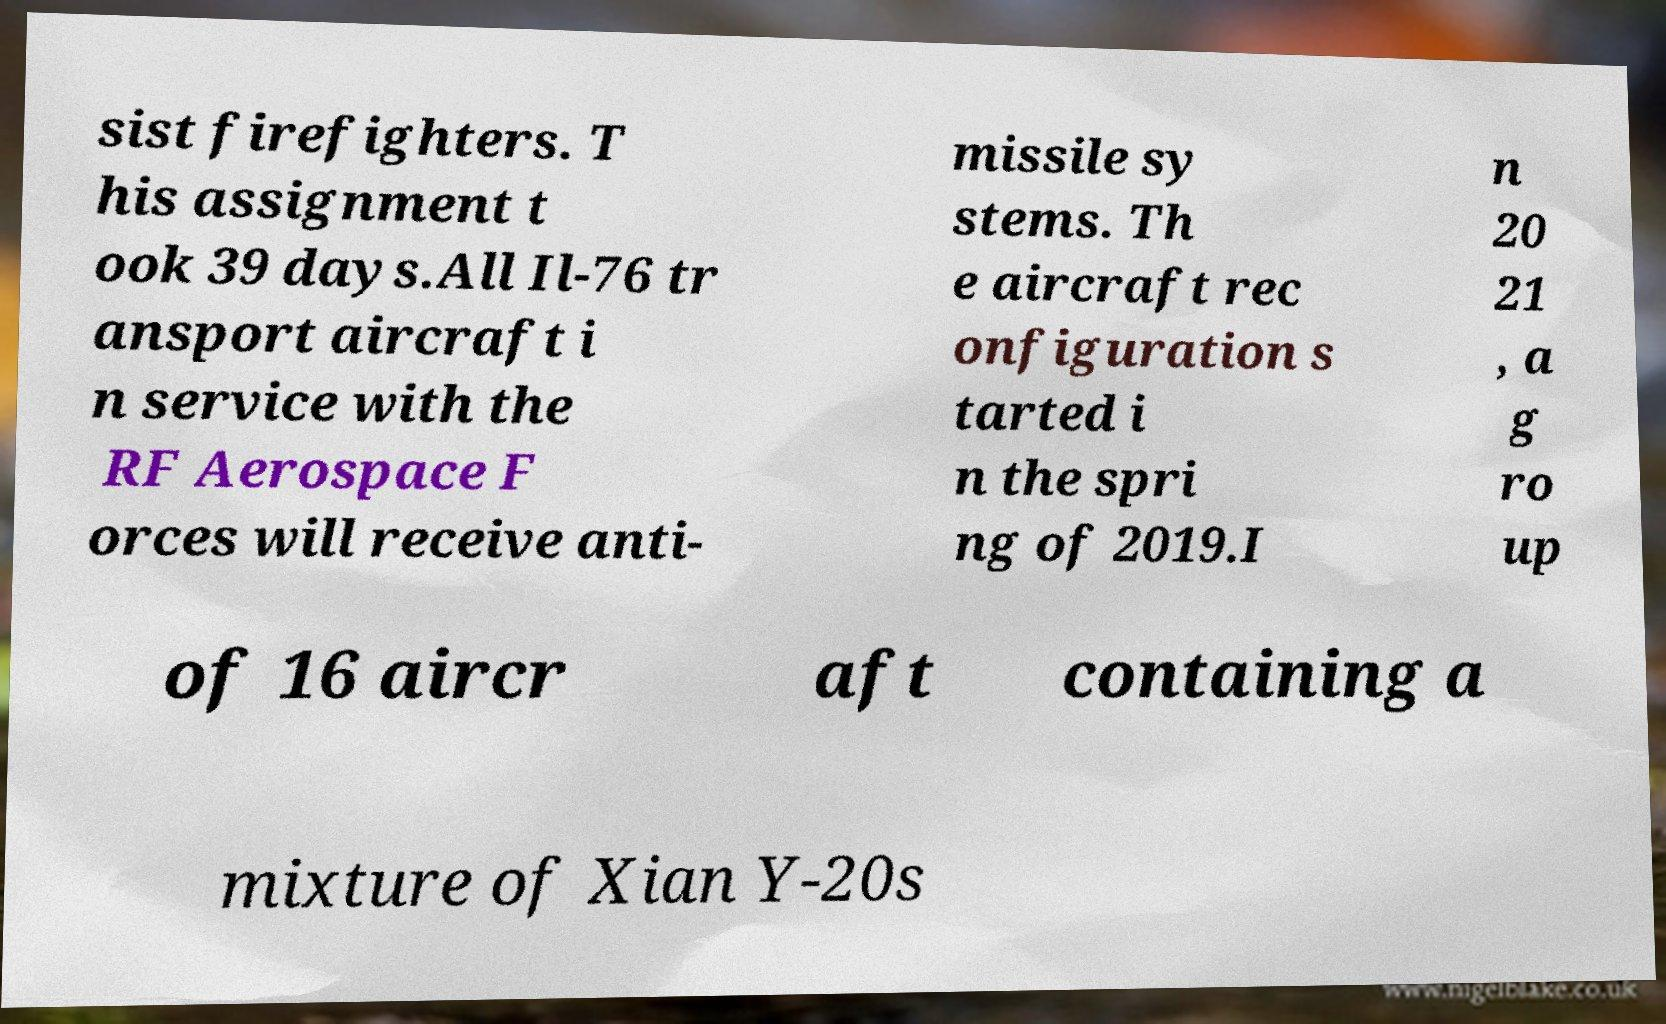For documentation purposes, I need the text within this image transcribed. Could you provide that? sist firefighters. T his assignment t ook 39 days.All Il-76 tr ansport aircraft i n service with the RF Aerospace F orces will receive anti- missile sy stems. Th e aircraft rec onfiguration s tarted i n the spri ng of 2019.I n 20 21 , a g ro up of 16 aircr aft containing a mixture of Xian Y-20s 